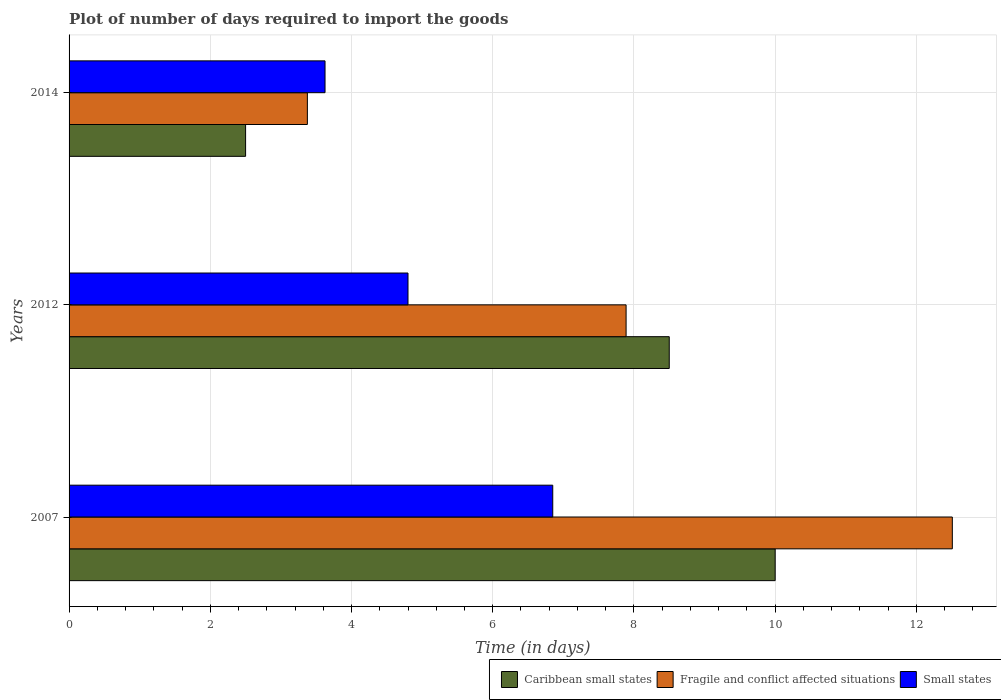How many different coloured bars are there?
Provide a short and direct response. 3. Are the number of bars per tick equal to the number of legend labels?
Offer a very short reply. Yes. In how many cases, is the number of bars for a given year not equal to the number of legend labels?
Offer a terse response. 0. What is the time required to import goods in Fragile and conflict affected situations in 2007?
Your response must be concise. 12.51. Across all years, what is the maximum time required to import goods in Small states?
Provide a succinct answer. 6.85. Across all years, what is the minimum time required to import goods in Fragile and conflict affected situations?
Ensure brevity in your answer.  3.38. In which year was the time required to import goods in Caribbean small states maximum?
Give a very brief answer. 2007. What is the total time required to import goods in Small states in the graph?
Provide a succinct answer. 15.27. What is the difference between the time required to import goods in Small states in 2014 and the time required to import goods in Caribbean small states in 2012?
Your response must be concise. -4.88. What is the average time required to import goods in Caribbean small states per year?
Keep it short and to the point. 7. In the year 2014, what is the difference between the time required to import goods in Caribbean small states and time required to import goods in Fragile and conflict affected situations?
Your answer should be compact. -0.88. What is the ratio of the time required to import goods in Fragile and conflict affected situations in 2007 to that in 2014?
Make the answer very short. 3.71. Is the time required to import goods in Small states in 2007 less than that in 2014?
Offer a very short reply. No. Is the difference between the time required to import goods in Caribbean small states in 2007 and 2014 greater than the difference between the time required to import goods in Fragile and conflict affected situations in 2007 and 2014?
Provide a succinct answer. No. What is the difference between the highest and the second highest time required to import goods in Small states?
Make the answer very short. 2.05. What is the difference between the highest and the lowest time required to import goods in Small states?
Keep it short and to the point. 3.22. What does the 1st bar from the top in 2007 represents?
Give a very brief answer. Small states. What does the 1st bar from the bottom in 2014 represents?
Your answer should be compact. Caribbean small states. Is it the case that in every year, the sum of the time required to import goods in Caribbean small states and time required to import goods in Small states is greater than the time required to import goods in Fragile and conflict affected situations?
Provide a short and direct response. Yes. Are all the bars in the graph horizontal?
Offer a very short reply. Yes. Does the graph contain any zero values?
Provide a short and direct response. No. How are the legend labels stacked?
Keep it short and to the point. Horizontal. What is the title of the graph?
Give a very brief answer. Plot of number of days required to import the goods. Does "Sri Lanka" appear as one of the legend labels in the graph?
Ensure brevity in your answer.  No. What is the label or title of the X-axis?
Make the answer very short. Time (in days). What is the Time (in days) of Fragile and conflict affected situations in 2007?
Provide a short and direct response. 12.51. What is the Time (in days) of Small states in 2007?
Your answer should be very brief. 6.85. What is the Time (in days) of Caribbean small states in 2012?
Make the answer very short. 8.5. What is the Time (in days) of Fragile and conflict affected situations in 2012?
Provide a succinct answer. 7.89. What is the Time (in days) of Small states in 2012?
Give a very brief answer. 4.8. What is the Time (in days) in Fragile and conflict affected situations in 2014?
Your answer should be very brief. 3.38. What is the Time (in days) of Small states in 2014?
Ensure brevity in your answer.  3.62. Across all years, what is the maximum Time (in days) in Fragile and conflict affected situations?
Your answer should be very brief. 12.51. Across all years, what is the maximum Time (in days) in Small states?
Your response must be concise. 6.85. Across all years, what is the minimum Time (in days) in Caribbean small states?
Ensure brevity in your answer.  2.5. Across all years, what is the minimum Time (in days) in Fragile and conflict affected situations?
Your response must be concise. 3.38. Across all years, what is the minimum Time (in days) in Small states?
Make the answer very short. 3.62. What is the total Time (in days) in Fragile and conflict affected situations in the graph?
Offer a terse response. 23.77. What is the total Time (in days) of Small states in the graph?
Give a very brief answer. 15.28. What is the difference between the Time (in days) in Caribbean small states in 2007 and that in 2012?
Offer a terse response. 1.5. What is the difference between the Time (in days) of Fragile and conflict affected situations in 2007 and that in 2012?
Keep it short and to the point. 4.62. What is the difference between the Time (in days) in Small states in 2007 and that in 2012?
Provide a short and direct response. 2.05. What is the difference between the Time (in days) in Caribbean small states in 2007 and that in 2014?
Offer a very short reply. 7.5. What is the difference between the Time (in days) in Fragile and conflict affected situations in 2007 and that in 2014?
Offer a very short reply. 9.13. What is the difference between the Time (in days) of Small states in 2007 and that in 2014?
Offer a terse response. 3.23. What is the difference between the Time (in days) of Fragile and conflict affected situations in 2012 and that in 2014?
Your answer should be very brief. 4.51. What is the difference between the Time (in days) of Small states in 2012 and that in 2014?
Your response must be concise. 1.18. What is the difference between the Time (in days) of Caribbean small states in 2007 and the Time (in days) of Fragile and conflict affected situations in 2012?
Offer a very short reply. 2.11. What is the difference between the Time (in days) of Fragile and conflict affected situations in 2007 and the Time (in days) of Small states in 2012?
Your answer should be compact. 7.71. What is the difference between the Time (in days) in Caribbean small states in 2007 and the Time (in days) in Fragile and conflict affected situations in 2014?
Provide a short and direct response. 6.62. What is the difference between the Time (in days) in Caribbean small states in 2007 and the Time (in days) in Small states in 2014?
Keep it short and to the point. 6.38. What is the difference between the Time (in days) of Fragile and conflict affected situations in 2007 and the Time (in days) of Small states in 2014?
Keep it short and to the point. 8.88. What is the difference between the Time (in days) in Caribbean small states in 2012 and the Time (in days) in Fragile and conflict affected situations in 2014?
Your answer should be compact. 5.12. What is the difference between the Time (in days) of Caribbean small states in 2012 and the Time (in days) of Small states in 2014?
Your response must be concise. 4.88. What is the difference between the Time (in days) in Fragile and conflict affected situations in 2012 and the Time (in days) in Small states in 2014?
Ensure brevity in your answer.  4.26. What is the average Time (in days) in Caribbean small states per year?
Keep it short and to the point. 7. What is the average Time (in days) of Fragile and conflict affected situations per year?
Your answer should be compact. 7.92. What is the average Time (in days) in Small states per year?
Make the answer very short. 5.09. In the year 2007, what is the difference between the Time (in days) of Caribbean small states and Time (in days) of Fragile and conflict affected situations?
Keep it short and to the point. -2.51. In the year 2007, what is the difference between the Time (in days) in Caribbean small states and Time (in days) in Small states?
Offer a terse response. 3.15. In the year 2007, what is the difference between the Time (in days) in Fragile and conflict affected situations and Time (in days) in Small states?
Offer a terse response. 5.66. In the year 2012, what is the difference between the Time (in days) of Caribbean small states and Time (in days) of Fragile and conflict affected situations?
Provide a short and direct response. 0.61. In the year 2012, what is the difference between the Time (in days) in Fragile and conflict affected situations and Time (in days) in Small states?
Keep it short and to the point. 3.09. In the year 2014, what is the difference between the Time (in days) in Caribbean small states and Time (in days) in Fragile and conflict affected situations?
Your response must be concise. -0.88. In the year 2014, what is the difference between the Time (in days) in Caribbean small states and Time (in days) in Small states?
Your answer should be compact. -1.12. In the year 2014, what is the difference between the Time (in days) of Fragile and conflict affected situations and Time (in days) of Small states?
Offer a very short reply. -0.25. What is the ratio of the Time (in days) of Caribbean small states in 2007 to that in 2012?
Ensure brevity in your answer.  1.18. What is the ratio of the Time (in days) in Fragile and conflict affected situations in 2007 to that in 2012?
Give a very brief answer. 1.59. What is the ratio of the Time (in days) of Small states in 2007 to that in 2012?
Your answer should be compact. 1.43. What is the ratio of the Time (in days) of Fragile and conflict affected situations in 2007 to that in 2014?
Offer a terse response. 3.71. What is the ratio of the Time (in days) in Small states in 2007 to that in 2014?
Keep it short and to the point. 1.89. What is the ratio of the Time (in days) of Caribbean small states in 2012 to that in 2014?
Offer a very short reply. 3.4. What is the ratio of the Time (in days) in Fragile and conflict affected situations in 2012 to that in 2014?
Ensure brevity in your answer.  2.34. What is the ratio of the Time (in days) of Small states in 2012 to that in 2014?
Keep it short and to the point. 1.32. What is the difference between the highest and the second highest Time (in days) of Fragile and conflict affected situations?
Keep it short and to the point. 4.62. What is the difference between the highest and the second highest Time (in days) in Small states?
Offer a terse response. 2.05. What is the difference between the highest and the lowest Time (in days) in Caribbean small states?
Offer a very short reply. 7.5. What is the difference between the highest and the lowest Time (in days) in Fragile and conflict affected situations?
Ensure brevity in your answer.  9.13. What is the difference between the highest and the lowest Time (in days) in Small states?
Ensure brevity in your answer.  3.23. 